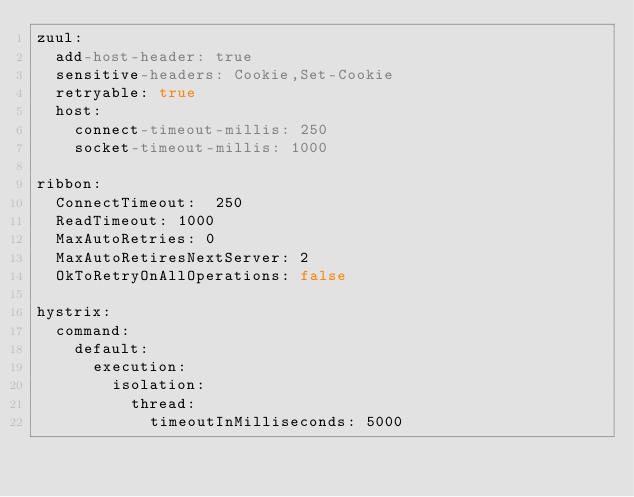<code> <loc_0><loc_0><loc_500><loc_500><_YAML_>zuul:
  add-host-header: true
  sensitive-headers: Cookie,Set-Cookie
  retryable: true
  host:
    connect-timeout-millis: 250
    socket-timeout-millis: 1000

ribbon:
  ConnectTimeout:  250
  ReadTimeout: 1000
  MaxAutoRetries: 0
  MaxAutoRetiresNextServer: 2
  OkToRetryOnAllOperations: false

hystrix:
  command:
    default:
      execution:
        isolation:
          thread:
            timeoutInMilliseconds: 5000
</code> 